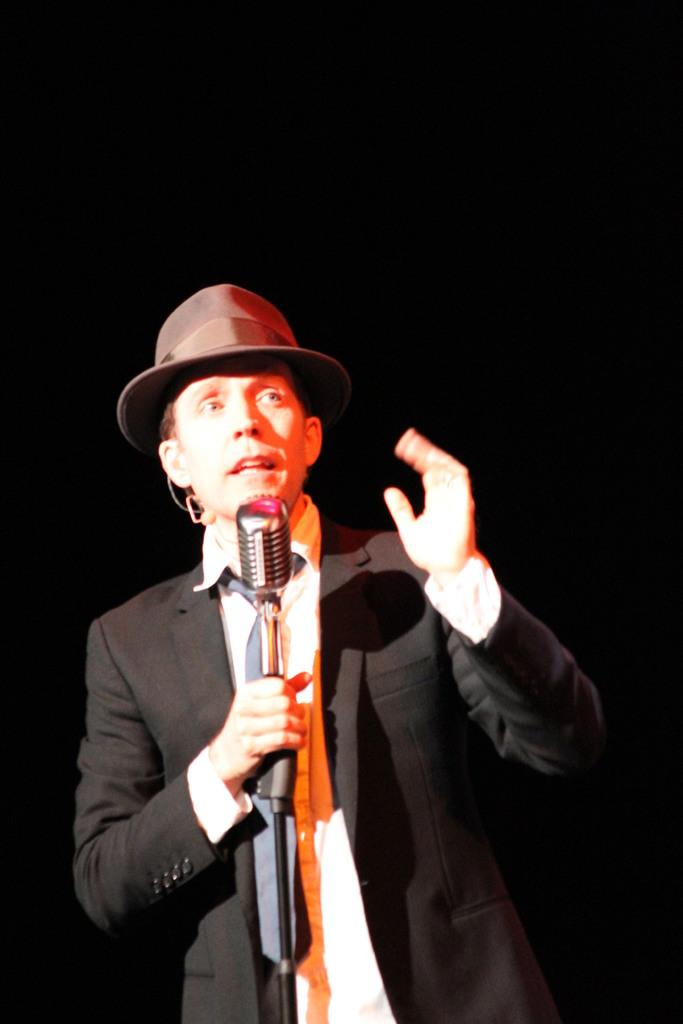Who is the main subject in the image? There is a guy in the image. What is the guy wearing? The guy is wearing a black coat. What is the guy holding in his hand? The guy is holding a microphone in his hand. What is the color of the background in the image? The background of the image is black in color. What type of riddle is the guy solving in the image? There is no riddle present in the image; the guy is holding a microphone. Can you see any scissors or pencils in the image? No, there are no scissors or pencils visible in the image. 